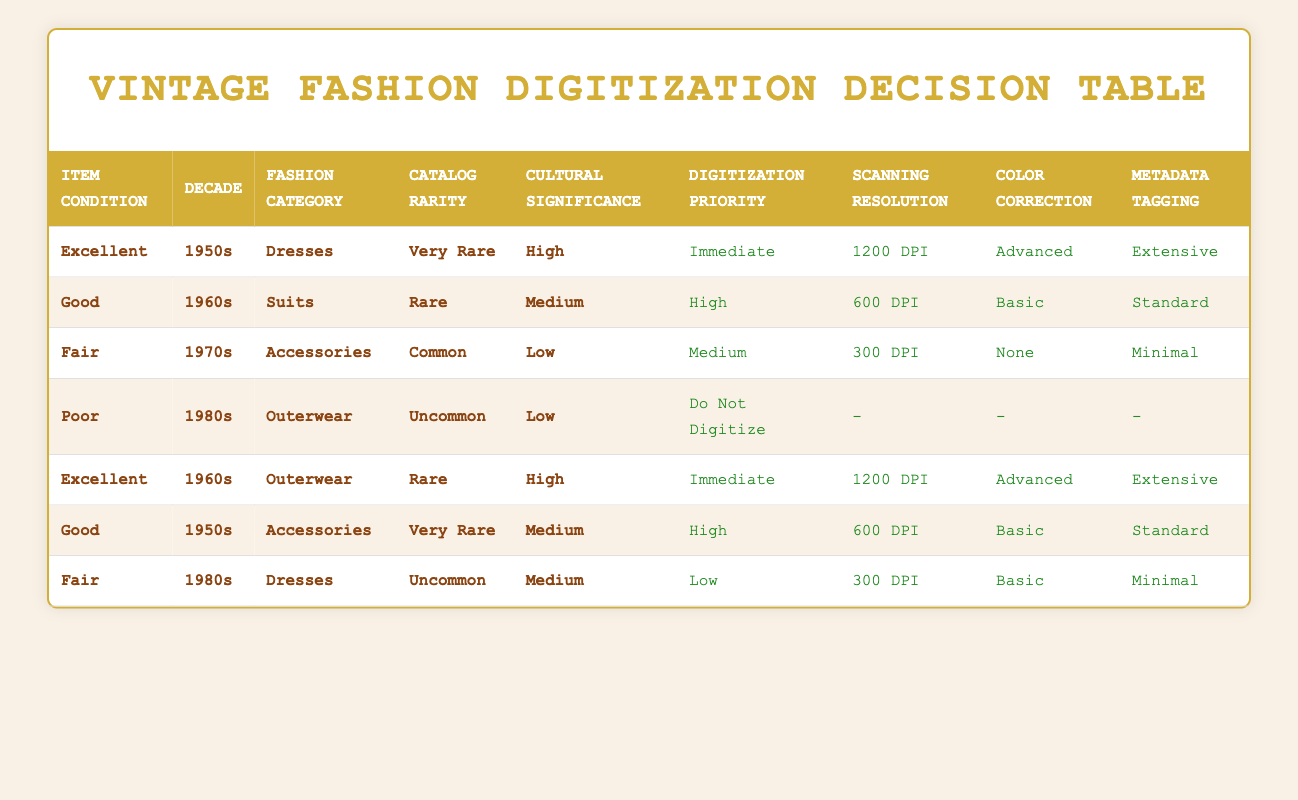What digitization priority is assigned to items in excellent condition from the 1950s? The table shows that for items in excellent condition from the 1950s, specifically for dresses that are very rare and high in cultural significance, the digitization priority is "Immediate."
Answer: Immediate Which scanning resolution is recommended for good condition suits from the 1960s? From the table, it can be seen that good condition suits from the 1960s that are rare and have medium cultural significance have a recommended scanning resolution of "600 DPI."
Answer: 600 DPI Are there any items listed that should not be digitized? Yes, the table indicates that there is one item, poor condition outerwear from the 1980s with low rarity and low cultural significance, which has the action "Do Not Digitize."
Answer: Yes What is the scanning resolution for fair condition accessories from the 1970s? The table states that fair condition accessories from the 1970s, which are common and have low cultural significance, are recommended to be scanned at "300 DPI."
Answer: 300 DPI How many different actions are taken for items in excellent condition across all decades? Examining the table, there are two items listed in excellent condition: one from the 1950s with an immediate action and one from the 1960s with the same immediate action. Thus, there are 2 actions for excellent condition items across all decades.
Answer: 2 